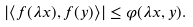Convert formula to latex. <formula><loc_0><loc_0><loc_500><loc_500>| \langle f ( \lambda x ) , f ( y ) \rangle | \leq \varphi ( \lambda x , y ) .</formula> 